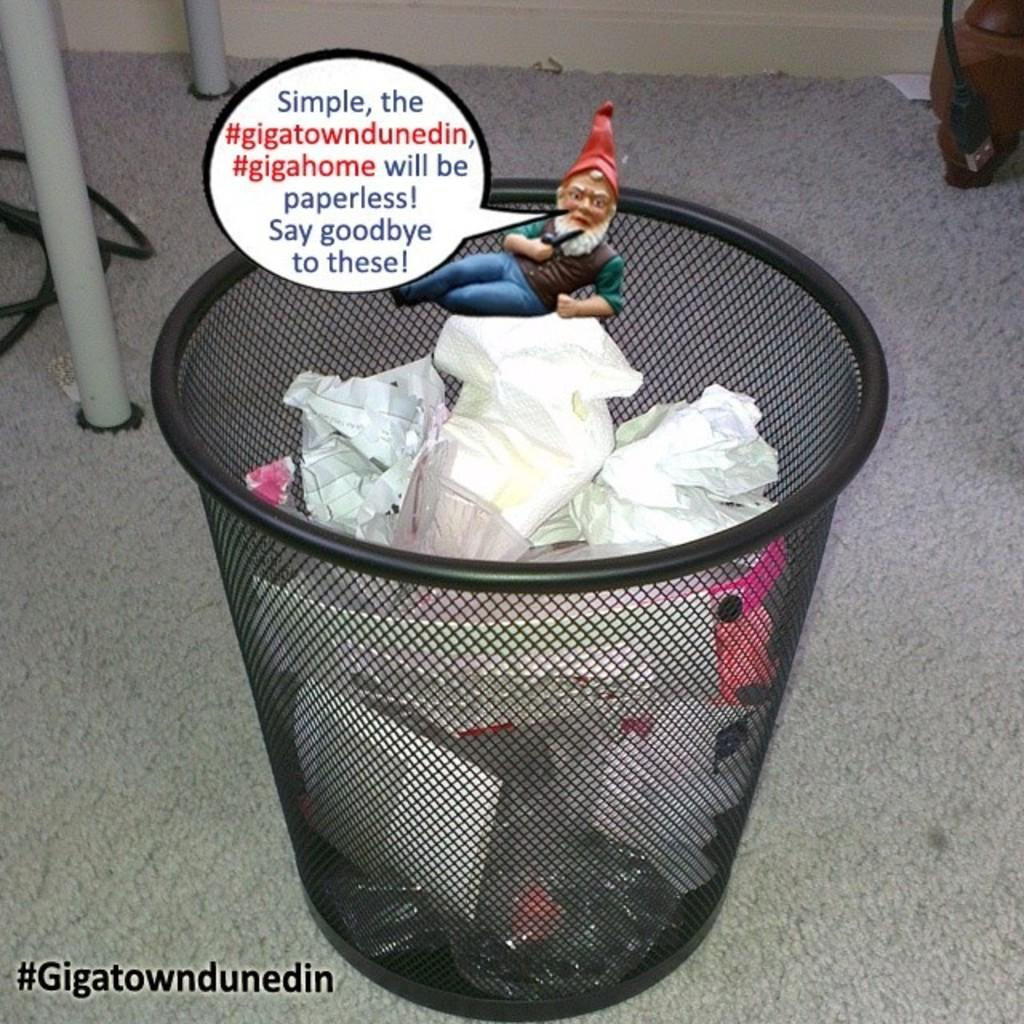<image>
Write a terse but informative summary of the picture. A message from the #Gigatowndunedin states that they will become paperless and will not need a garbage can. 